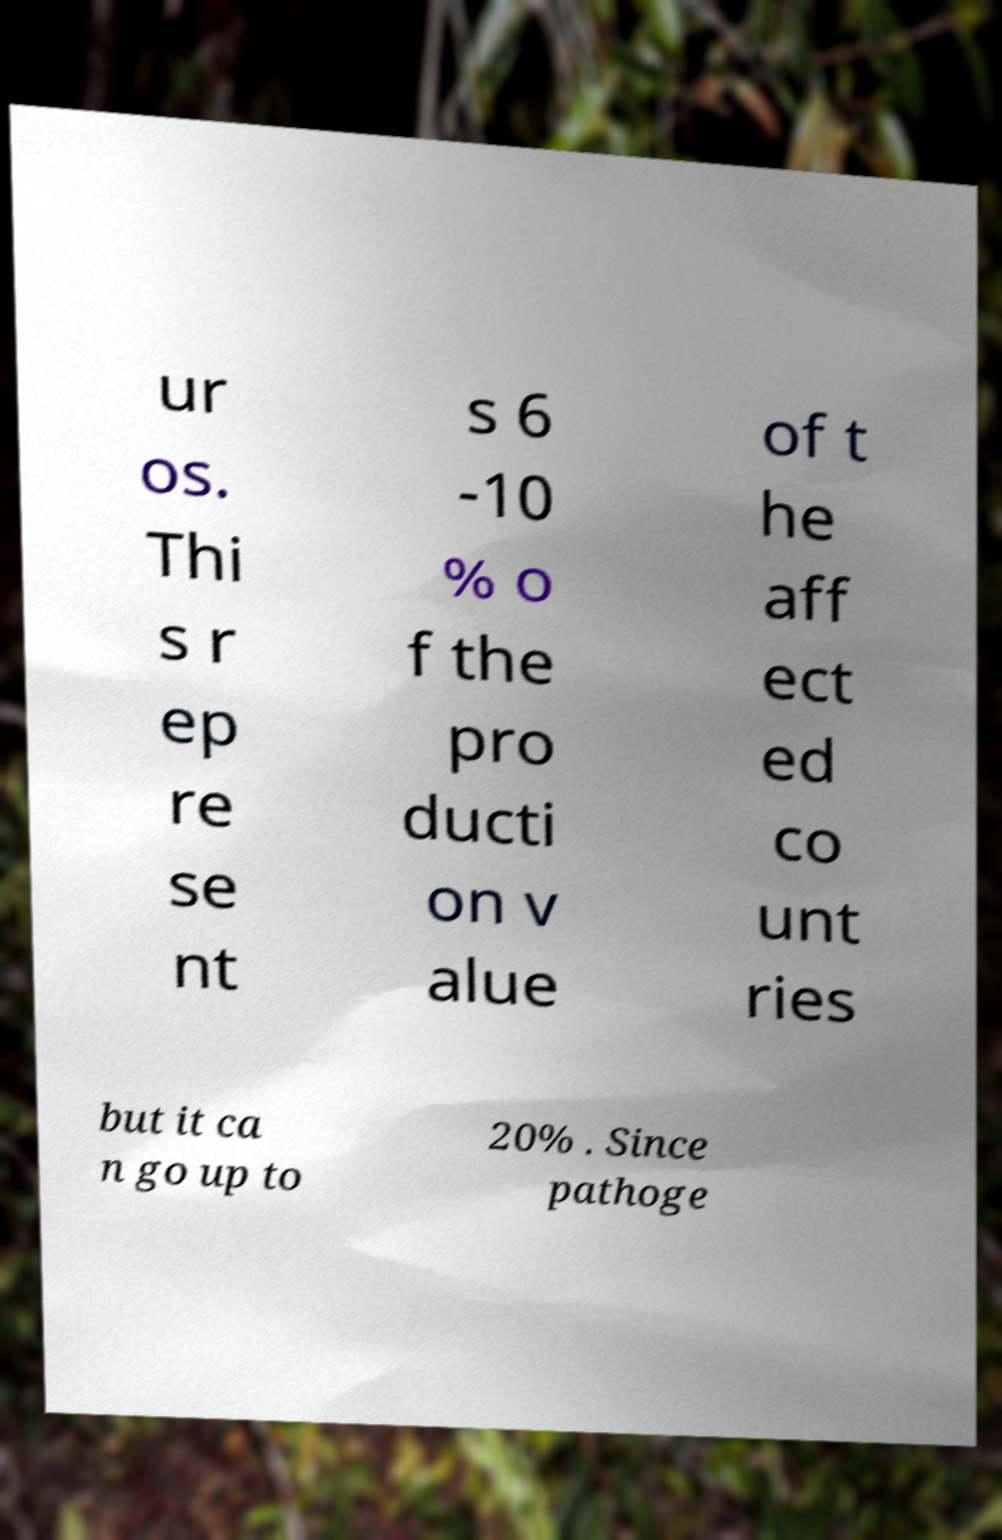What messages or text are displayed in this image? I need them in a readable, typed format. ur os. Thi s r ep re se nt s 6 -10 % o f the pro ducti on v alue of t he aff ect ed co unt ries but it ca n go up to 20% . Since pathoge 